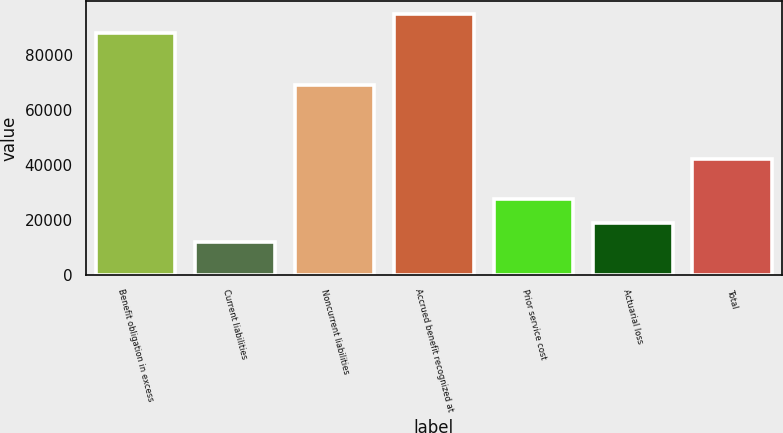<chart> <loc_0><loc_0><loc_500><loc_500><bar_chart><fcel>Benefit obligation in excess<fcel>Current liabilities<fcel>Noncurrent liabilities<fcel>Accrued benefit recognized at<fcel>Prior service cost<fcel>Actuarial loss<fcel>Total<nl><fcel>88137.7<fcel>11900<fcel>69307<fcel>95068.4<fcel>27523<fcel>18830.7<fcel>42220<nl></chart> 